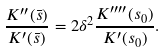<formula> <loc_0><loc_0><loc_500><loc_500>\frac { K ^ { \prime \prime } ( \bar { s } ) } { K ^ { \prime } ( \bar { s } ) } = 2 \delta ^ { 2 } \frac { K ^ { \prime \prime \prime \prime } ( s _ { 0 } ) } { K ^ { \prime } ( s _ { 0 } ) } .</formula> 